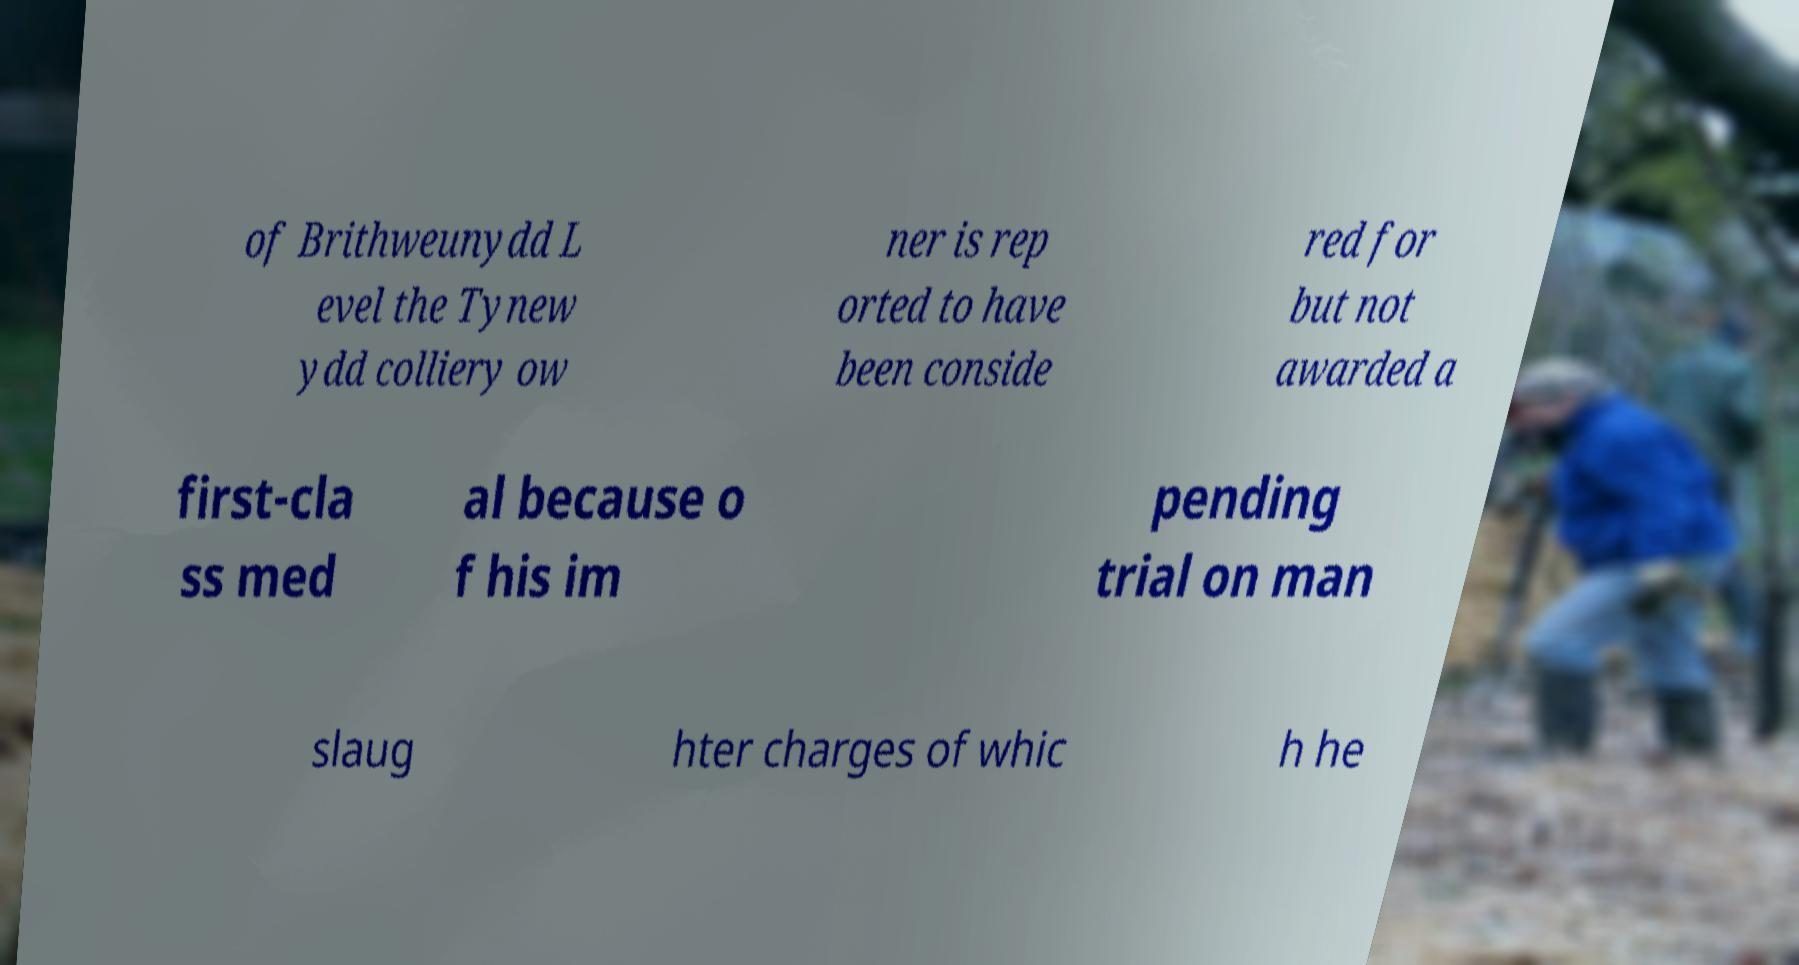Can you accurately transcribe the text from the provided image for me? of Brithweunydd L evel the Tynew ydd colliery ow ner is rep orted to have been conside red for but not awarded a first-cla ss med al because o f his im pending trial on man slaug hter charges of whic h he 